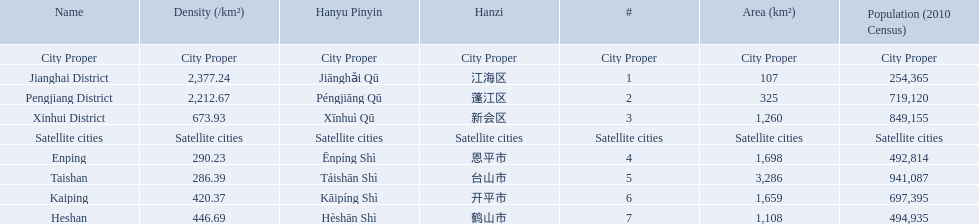What city propers are listed? Jianghai District, Pengjiang District, Xinhui District. Which hast he smallest area in km2? Jianghai District. 